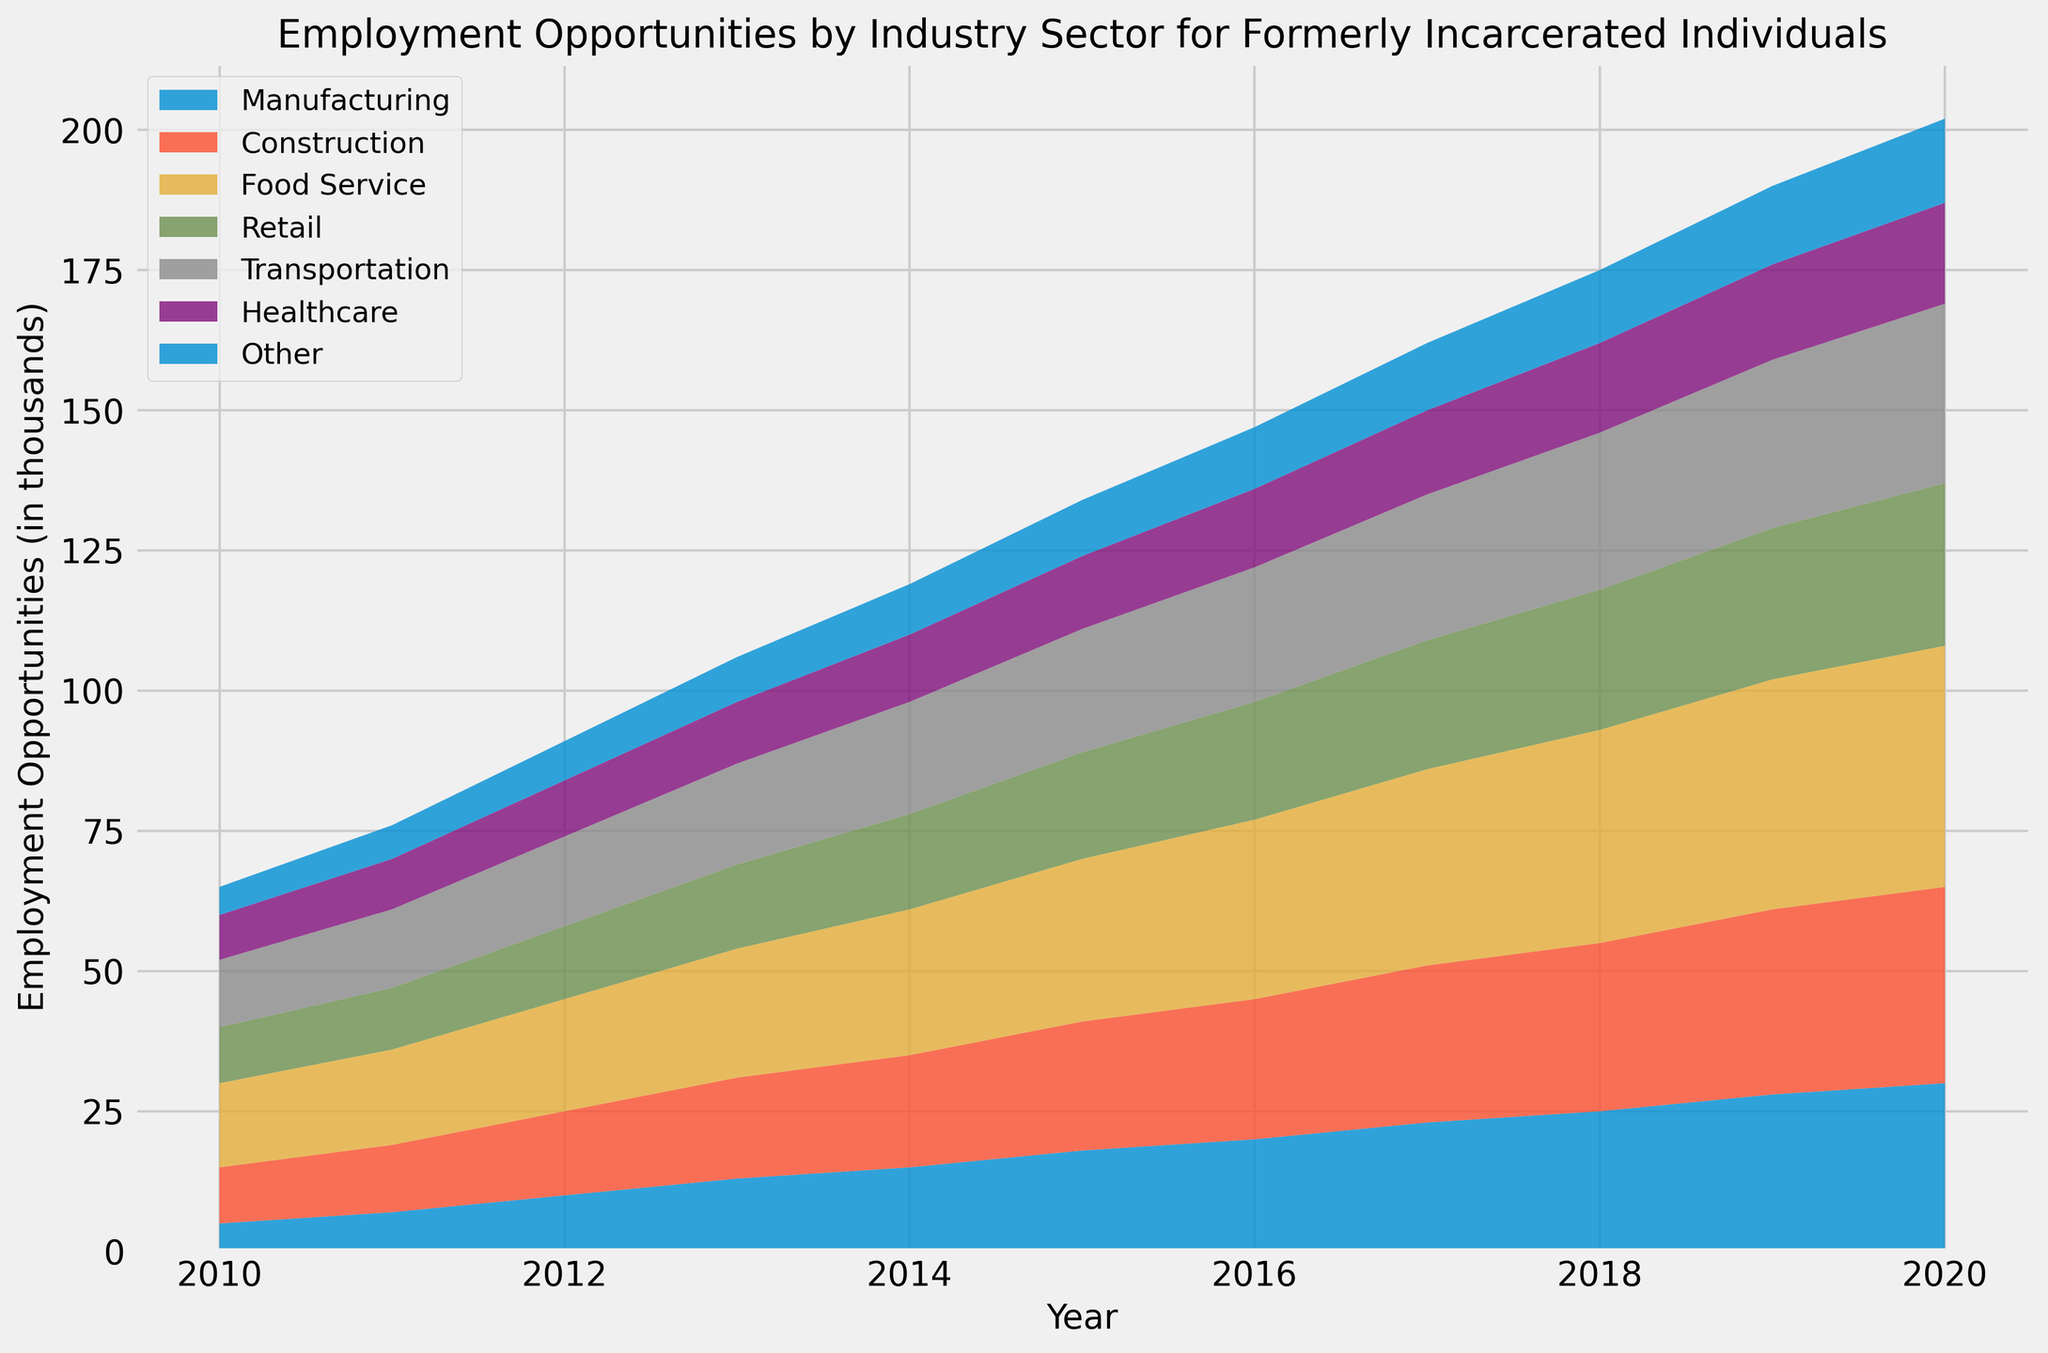What's the trend for employment opportunities in the Food Service sector from 2010 to 2020? The area chart shows the values for the Food Service sector increasing consistently each year. In 2010, employment opportunities were at 15 thousand and reached 43 thousand by 2020. This trend demonstrates a steady rise over the years.
Answer: Increasing Which industry sector had the largest increase in employment opportunities from 2010 to 2020? By examining the area sizes and the numerical progression, the Food Service sector had a noticeable increase, from 15 thousand in 2010 to 43 thousand in 2020, which is a 28 thousand increase. Comparing this with other sectors, Food Service shows the largest growth.
Answer: Food Service In 2017, is the number of employment opportunities in Healthcare greater than in Transportation? By looking at the stacking order and values for 2017, Healthcare shows around 15 thousand, while Transportation shows approximately 26 thousand in opportunities. So, Transportation has more employment opportunities than Healthcare in 2017.
Answer: No What is the combined number of employment opportunities in Construction and Healthcare in 2015? For 2015, Construction has 23 thousand opportunities and Healthcare has 13 thousand. Adding those gives 23 + 13 = 36 thousand opportunities combined.
Answer: 36 thousand Which year showed the first instance of Manufacturing surpassing 20 thousand employment opportunities? By checking the values over the years for Manufacturing, it first surpasses 20 thousand in 2016, where it shows exactly 20 thousand opportunities.
Answer: 2016 During which year did Transportation employment opportunities reach 30 thousand? Transportation employment opportunities reach 30 thousand in 2019 based on the stack size and year labels.
Answer: 2019 Which sector had the smallest change in employment opportunities from 2010 to 2020? By comparing the initial and final values for each sector, Other increased from 5 thousand to 15 thousand, which is the smallest change among all sectors.
Answer: Other In 2020, what is the difference between the employment opportunities in Retail and Manufacturing sectors? Retail in 2020 has 29 thousand opportunities, while Manufacturing has 30 thousand. The difference is 30 - 29 = 1 thousand.
Answer: 1 thousand How does the area representing Transportation compare to that of Healthcare in 2014? In 2014, the Transportation area is visually larger and numerically higher at around 20 thousand compared to Healthcare’s 12 thousand.
Answer: Larger 